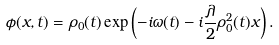Convert formula to latex. <formula><loc_0><loc_0><loc_500><loc_500>\phi ( x , t ) = \rho _ { 0 } ( t ) \exp \left ( - i \omega ( t ) - i \frac { \lambda } { 2 } \rho _ { 0 } ^ { 2 } ( t ) x \right ) .</formula> 